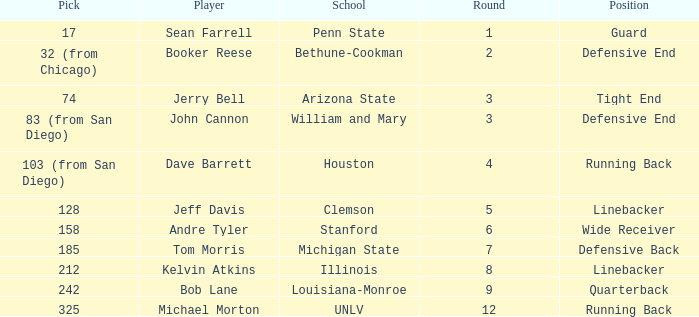Which round was Tom Morris picked in? 1.0. 